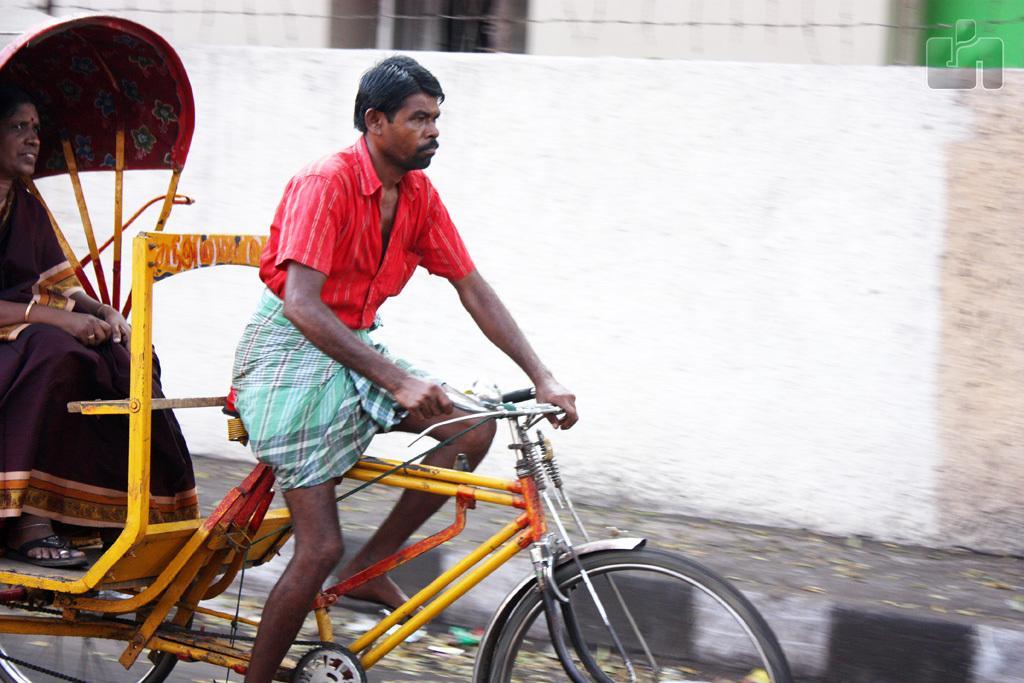Please provide a concise description of this image. This is a man sitting and riding rickshaw and here is the woman sitting inside the rickshaw. At background this looks like a compound wall of the building. 